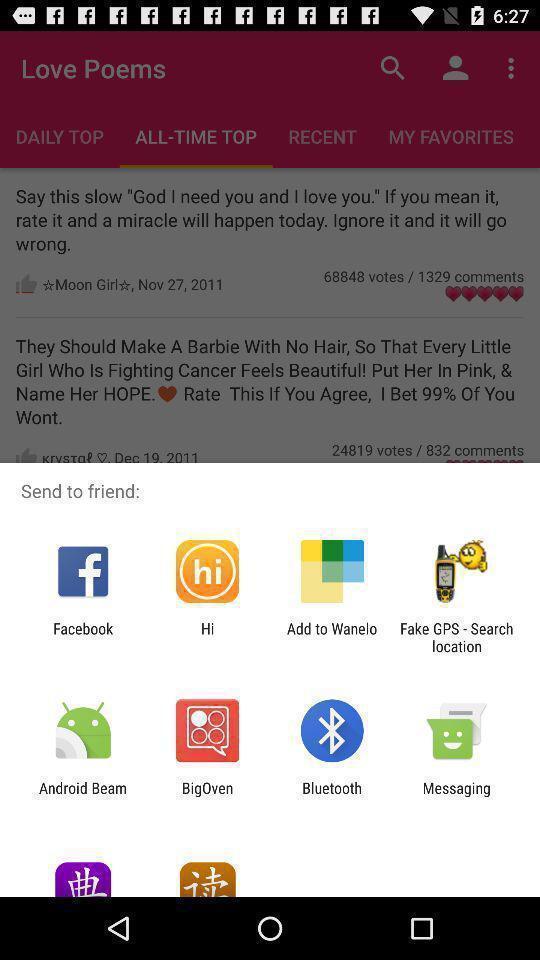What can you discern from this picture? Screen displaying multiple sending applications. 